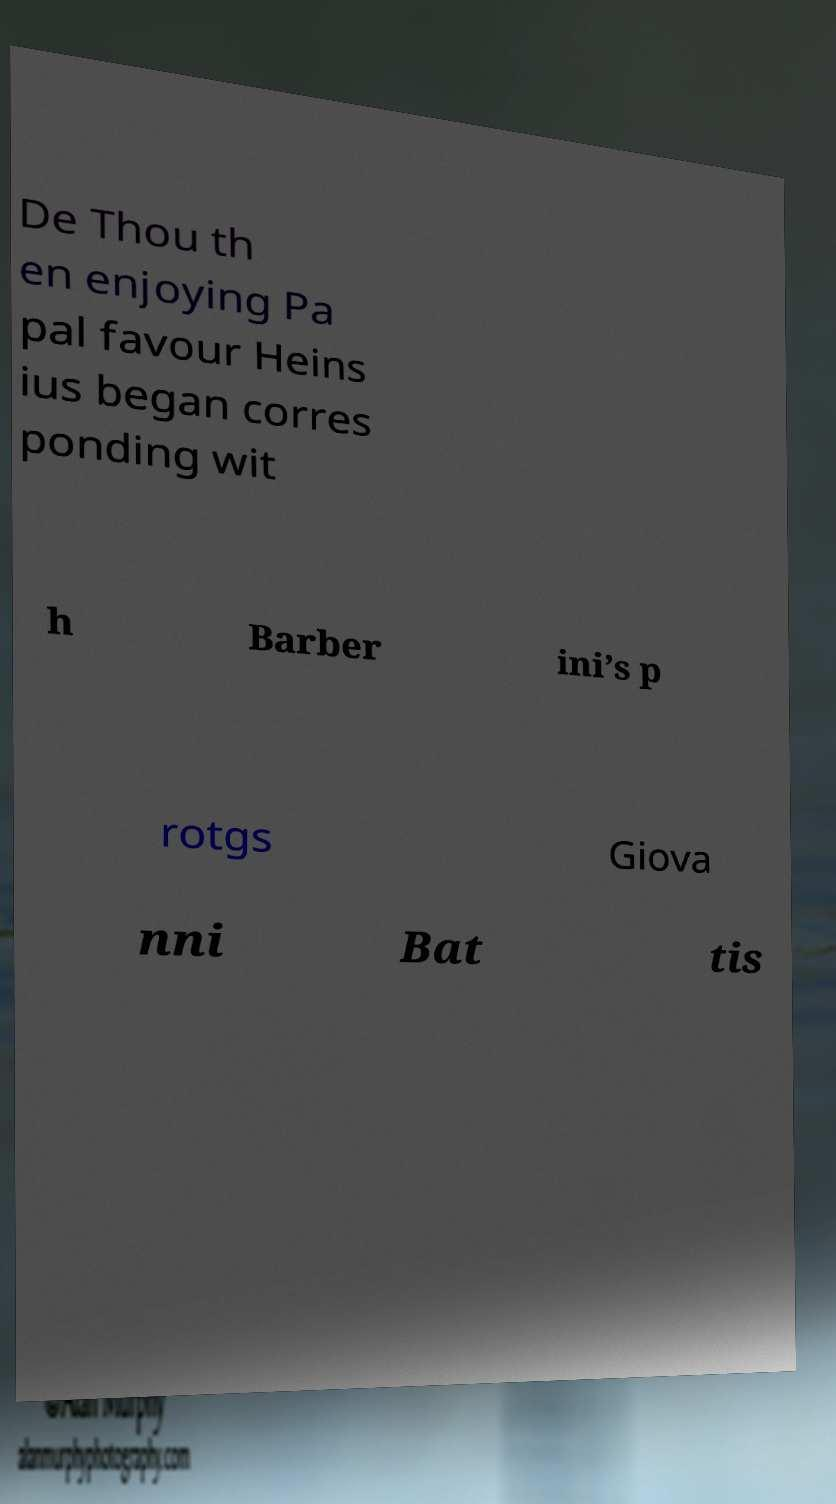Please identify and transcribe the text found in this image. De Thou th en enjoying Pa pal favour Heins ius began corres ponding wit h Barber ini’s p rotgs Giova nni Bat tis 